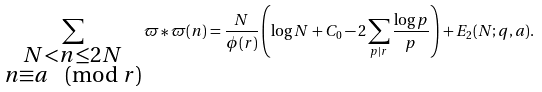<formula> <loc_0><loc_0><loc_500><loc_500>\sum _ { \substack { N < n \leq 2 N \\ n \equiv a \pmod { r } } } \varpi * \varpi ( n ) = \frac { N } { \phi ( r ) } \left ( \log N + C _ { 0 } - 2 \sum _ { p | r } \frac { \log p } { p } \right ) + E _ { 2 } ( N ; q , a ) .</formula> 